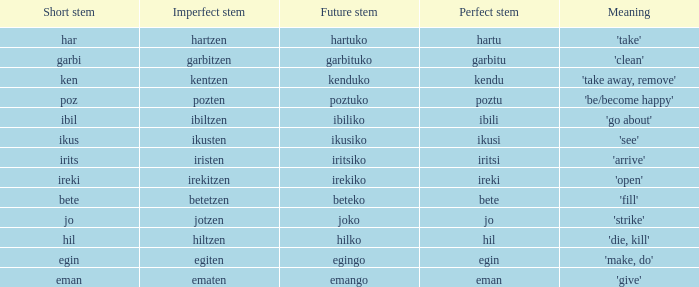What is the perfect stem for pozten? Poztu. 